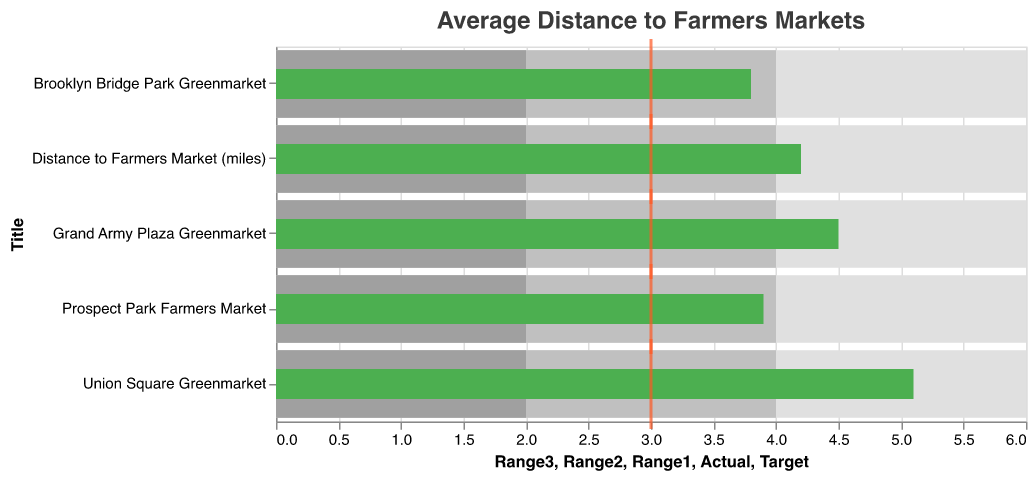What's the title of the figure? The title of the figure is displayed at the top and reads "Average Distance to Farmers Markets".
Answer: Average Distance to Farmers Markets How many farmers markets are represented in the figure? By counting the different titles along the y-axis, which represent the different farmers markets, we can see there are 5 farmers markets listed.
Answer: 5 Which farmers market has the highest actual distance traveled? By looking at the green bars representing the actual distances, we can see that Union Square Greenmarket has the highest actual distance of 5.1 miles.
Answer: Union Square Greenmarket Is the average distance to farmers markets above or below the target distance? The actual distance for the average is 4.2 miles, as shown by the green bar, which is above the target distance of 3 miles indicated by the red tick.
Answer: Above What is the target distance to farmers markets in miles? The target distance is indicated by the red tick mark on each bar, which is set at 3 miles.
Answer: 3 miles How does Union Square Greenmarket's actual distance compare to its target distance? Union Square Greenmarket's actual distance is 5.1 miles, compared to its target distance of 3 miles, which means it exceeds the target by 2.1 miles.
Answer: Exceeds by 2.1 miles Which farmers market is closest to meeting the target distance? By comparing all the green bars and their respective red tick marks, Brooklyn Bridge Park Greenmarket, with an actual distance of 3.8 miles, is closest to the target distance of 3 miles.
Answer: Brooklyn Bridge Park Greenmarket Compare the average actual distance to the average range. Is it within any of the range categories? The average actual distance is 4.2 miles. It falls within the second range category which spans from 2 to 4 miles but slightly exceeds it on the higher end.
Answer: Slightly exceeds the second range How much greater is Grand Army Plaza Greenmarket's actual distance than Brooklyn Bridge Park Greenmarket's? The actual distance for Grand Army Plaza Greenmarket is 4.5 miles, and for Brooklyn Bridge Park Greenmarket, it is 3.8 miles. The difference is 4.5 - 3.8 = 0.7 miles.
Answer: 0.7 miles Which farmers markets have their actual distances within the first range (0-2 miles)? Based on the visual information, no farmers markets have actual distances within the first range of 0-2 miles as all the green bars are beyond 2 miles.
Answer: None 